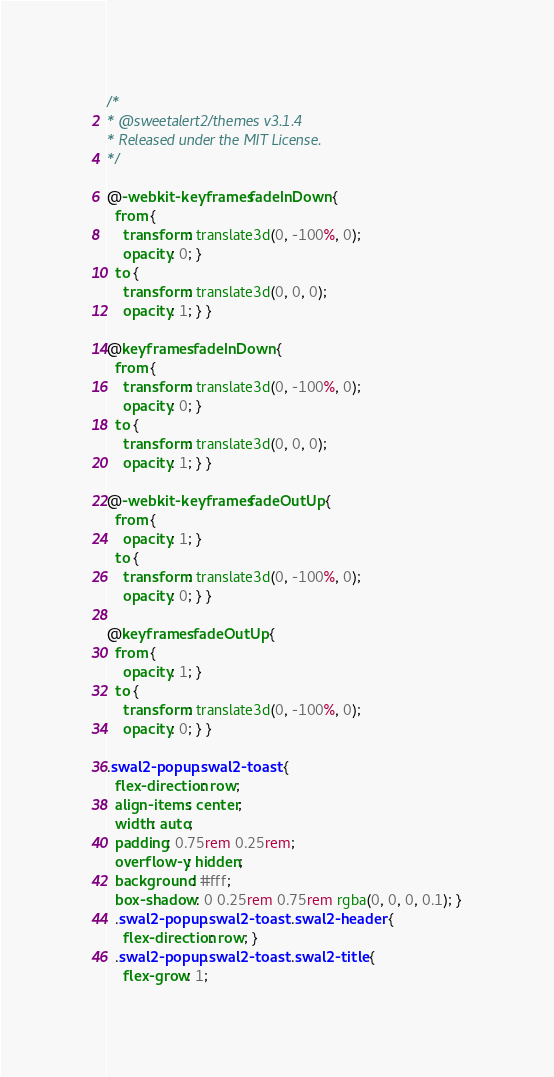Convert code to text. <code><loc_0><loc_0><loc_500><loc_500><_CSS_>/*
* @sweetalert2/themes v3.1.4
* Released under the MIT License.
*/

@-webkit-keyframes fadeInDown {
  from {
    transform: translate3d(0, -100%, 0);
    opacity: 0; }
  to {
    transform: translate3d(0, 0, 0);
    opacity: 1; } }

@keyframes fadeInDown {
  from {
    transform: translate3d(0, -100%, 0);
    opacity: 0; }
  to {
    transform: translate3d(0, 0, 0);
    opacity: 1; } }

@-webkit-keyframes fadeOutUp {
  from {
    opacity: 1; }
  to {
    transform: translate3d(0, -100%, 0);
    opacity: 0; } }

@keyframes fadeOutUp {
  from {
    opacity: 1; }
  to {
    transform: translate3d(0, -100%, 0);
    opacity: 0; } }

.swal2-popup.swal2-toast {
  flex-direction: row;
  align-items: center;
  width: auto;
  padding: 0.75rem 0.25rem;
  overflow-y: hidden;
  background: #fff;
  box-shadow: 0 0.25rem 0.75rem rgba(0, 0, 0, 0.1); }
  .swal2-popup.swal2-toast .swal2-header {
    flex-direction: row; }
  .swal2-popup.swal2-toast .swal2-title {
    flex-grow: 1;</code> 